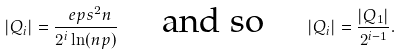<formula> <loc_0><loc_0><loc_500><loc_500>| Q _ { i } | = \frac { \ e p s ^ { 2 } n } { 2 ^ { i } \ln ( n p ) } \quad \ \text {and so} \quad \ | Q _ { i } | = \frac { | Q _ { 1 } | } { 2 ^ { i - 1 } } .</formula> 